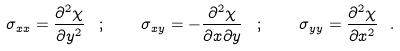<formula> <loc_0><loc_0><loc_500><loc_500>\sigma _ { x x } = \frac { \partial ^ { 2 } \chi } { \partial y ^ { 2 } } \, \ ; \quad \sigma _ { x y } = - \frac { \partial ^ { 2 } \chi } { \partial x \partial y } \, \ ; \quad \sigma _ { y y } = \frac { \partial ^ { 2 } \chi } { \partial x ^ { 2 } } \ .</formula> 